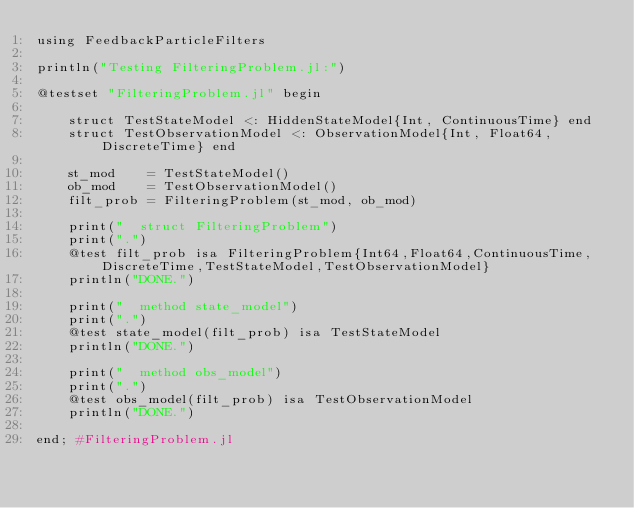Convert code to text. <code><loc_0><loc_0><loc_500><loc_500><_Julia_>using FeedbackParticleFilters

println("Testing FilteringProblem.jl:")

@testset "FilteringProblem.jl" begin
    
    struct TestStateModel <: HiddenStateModel{Int, ContinuousTime} end
    struct TestObservationModel <: ObservationModel{Int, Float64, DiscreteTime} end

    st_mod    = TestStateModel()
    ob_mod    = TestObservationModel()
    filt_prob = FilteringProblem(st_mod, ob_mod)
    
    print("  struct FilteringProblem")
    print(".")
    @test filt_prob isa FilteringProblem{Int64,Float64,ContinuousTime,DiscreteTime,TestStateModel,TestObservationModel}
    println("DONE.")
    
    print("  method state_model")
    print(".")
    @test state_model(filt_prob) isa TestStateModel
    println("DONE.")
    
    print("  method obs_model")
    print(".")
    @test obs_model(filt_prob) isa TestObservationModel
    println("DONE.")
    
end; #FilteringProblem.jl</code> 